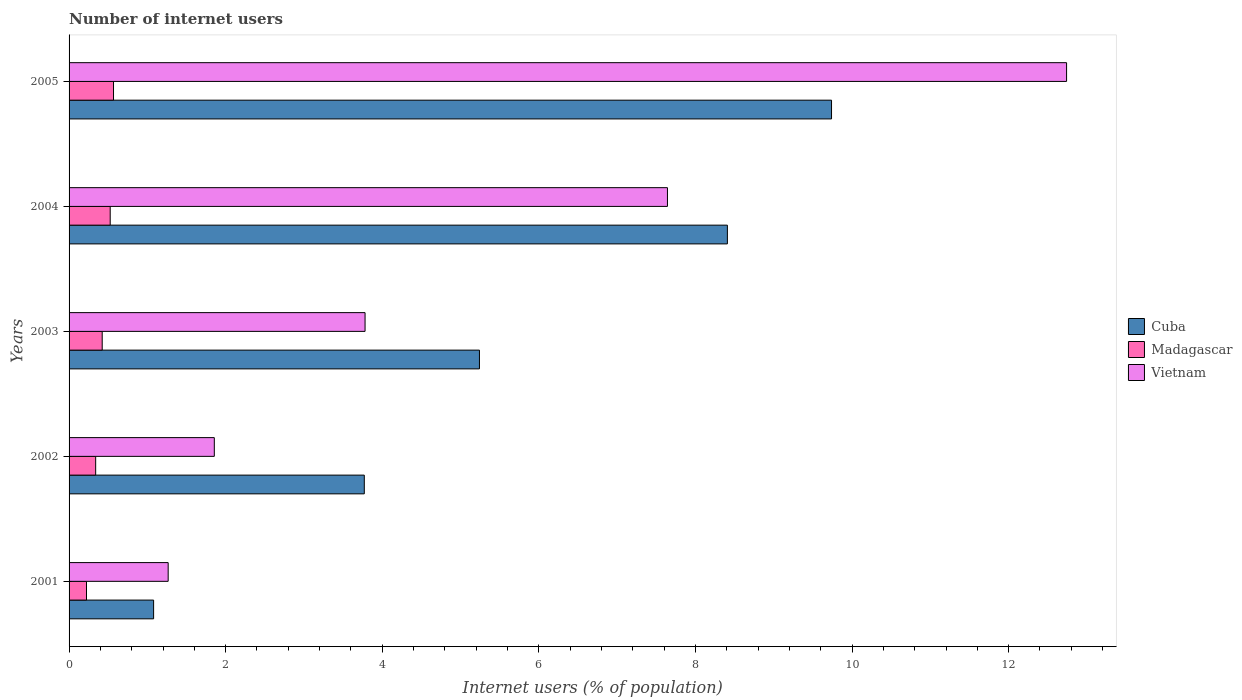How many different coloured bars are there?
Keep it short and to the point. 3. Are the number of bars per tick equal to the number of legend labels?
Provide a short and direct response. Yes. Are the number of bars on each tick of the Y-axis equal?
Offer a terse response. Yes. What is the number of internet users in Vietnam in 2002?
Your answer should be very brief. 1.85. Across all years, what is the maximum number of internet users in Madagascar?
Ensure brevity in your answer.  0.57. Across all years, what is the minimum number of internet users in Vietnam?
Offer a very short reply. 1.27. In which year was the number of internet users in Cuba maximum?
Provide a succinct answer. 2005. What is the total number of internet users in Cuba in the graph?
Provide a short and direct response. 28.24. What is the difference between the number of internet users in Madagascar in 2001 and that in 2002?
Your answer should be very brief. -0.12. What is the difference between the number of internet users in Cuba in 2005 and the number of internet users in Vietnam in 2002?
Provide a short and direct response. 7.88. What is the average number of internet users in Vietnam per year?
Give a very brief answer. 5.46. In the year 2004, what is the difference between the number of internet users in Vietnam and number of internet users in Madagascar?
Offer a very short reply. 7.12. What is the ratio of the number of internet users in Madagascar in 2003 to that in 2004?
Offer a very short reply. 0.81. What is the difference between the highest and the second highest number of internet users in Vietnam?
Offer a terse response. 5.1. What is the difference between the highest and the lowest number of internet users in Vietnam?
Keep it short and to the point. 11.47. In how many years, is the number of internet users in Cuba greater than the average number of internet users in Cuba taken over all years?
Give a very brief answer. 2. What does the 1st bar from the top in 2002 represents?
Make the answer very short. Vietnam. What does the 3rd bar from the bottom in 2004 represents?
Provide a short and direct response. Vietnam. What is the difference between two consecutive major ticks on the X-axis?
Your answer should be compact. 2. Are the values on the major ticks of X-axis written in scientific E-notation?
Your answer should be compact. No. Where does the legend appear in the graph?
Keep it short and to the point. Center right. How are the legend labels stacked?
Your answer should be very brief. Vertical. What is the title of the graph?
Offer a very short reply. Number of internet users. Does "Lebanon" appear as one of the legend labels in the graph?
Ensure brevity in your answer.  No. What is the label or title of the X-axis?
Give a very brief answer. Internet users (% of population). What is the Internet users (% of population) in Cuba in 2001?
Your answer should be very brief. 1.08. What is the Internet users (% of population) of Madagascar in 2001?
Ensure brevity in your answer.  0.22. What is the Internet users (% of population) in Vietnam in 2001?
Offer a terse response. 1.27. What is the Internet users (% of population) of Cuba in 2002?
Ensure brevity in your answer.  3.77. What is the Internet users (% of population) of Madagascar in 2002?
Your answer should be compact. 0.34. What is the Internet users (% of population) of Vietnam in 2002?
Keep it short and to the point. 1.85. What is the Internet users (% of population) of Cuba in 2003?
Provide a succinct answer. 5.24. What is the Internet users (% of population) in Madagascar in 2003?
Make the answer very short. 0.42. What is the Internet users (% of population) in Vietnam in 2003?
Your response must be concise. 3.78. What is the Internet users (% of population) in Cuba in 2004?
Ensure brevity in your answer.  8.41. What is the Internet users (% of population) in Madagascar in 2004?
Ensure brevity in your answer.  0.53. What is the Internet users (% of population) of Vietnam in 2004?
Your response must be concise. 7.64. What is the Internet users (% of population) in Cuba in 2005?
Offer a terse response. 9.74. What is the Internet users (% of population) in Madagascar in 2005?
Your answer should be compact. 0.57. What is the Internet users (% of population) in Vietnam in 2005?
Your answer should be compact. 12.74. Across all years, what is the maximum Internet users (% of population) in Cuba?
Your response must be concise. 9.74. Across all years, what is the maximum Internet users (% of population) in Madagascar?
Keep it short and to the point. 0.57. Across all years, what is the maximum Internet users (% of population) of Vietnam?
Offer a very short reply. 12.74. Across all years, what is the minimum Internet users (% of population) of Cuba?
Offer a terse response. 1.08. Across all years, what is the minimum Internet users (% of population) of Madagascar?
Keep it short and to the point. 0.22. Across all years, what is the minimum Internet users (% of population) in Vietnam?
Keep it short and to the point. 1.27. What is the total Internet users (% of population) in Cuba in the graph?
Your answer should be compact. 28.24. What is the total Internet users (% of population) in Madagascar in the graph?
Ensure brevity in your answer.  2.08. What is the total Internet users (% of population) in Vietnam in the graph?
Provide a succinct answer. 27.28. What is the difference between the Internet users (% of population) of Cuba in 2001 and that in 2002?
Offer a terse response. -2.69. What is the difference between the Internet users (% of population) of Madagascar in 2001 and that in 2002?
Your response must be concise. -0.12. What is the difference between the Internet users (% of population) of Vietnam in 2001 and that in 2002?
Make the answer very short. -0.59. What is the difference between the Internet users (% of population) in Cuba in 2001 and that in 2003?
Your answer should be compact. -4.16. What is the difference between the Internet users (% of population) of Madagascar in 2001 and that in 2003?
Give a very brief answer. -0.2. What is the difference between the Internet users (% of population) of Vietnam in 2001 and that in 2003?
Your response must be concise. -2.51. What is the difference between the Internet users (% of population) of Cuba in 2001 and that in 2004?
Your answer should be very brief. -7.33. What is the difference between the Internet users (% of population) in Madagascar in 2001 and that in 2004?
Provide a succinct answer. -0.3. What is the difference between the Internet users (% of population) in Vietnam in 2001 and that in 2004?
Offer a very short reply. -6.38. What is the difference between the Internet users (% of population) in Cuba in 2001 and that in 2005?
Offer a terse response. -8.66. What is the difference between the Internet users (% of population) of Madagascar in 2001 and that in 2005?
Offer a very short reply. -0.35. What is the difference between the Internet users (% of population) of Vietnam in 2001 and that in 2005?
Provide a succinct answer. -11.47. What is the difference between the Internet users (% of population) in Cuba in 2002 and that in 2003?
Keep it short and to the point. -1.47. What is the difference between the Internet users (% of population) of Madagascar in 2002 and that in 2003?
Offer a very short reply. -0.08. What is the difference between the Internet users (% of population) of Vietnam in 2002 and that in 2003?
Your answer should be very brief. -1.93. What is the difference between the Internet users (% of population) in Cuba in 2002 and that in 2004?
Offer a very short reply. -4.64. What is the difference between the Internet users (% of population) in Madagascar in 2002 and that in 2004?
Give a very brief answer. -0.19. What is the difference between the Internet users (% of population) in Vietnam in 2002 and that in 2004?
Keep it short and to the point. -5.79. What is the difference between the Internet users (% of population) in Cuba in 2002 and that in 2005?
Give a very brief answer. -5.97. What is the difference between the Internet users (% of population) of Madagascar in 2002 and that in 2005?
Your response must be concise. -0.23. What is the difference between the Internet users (% of population) of Vietnam in 2002 and that in 2005?
Make the answer very short. -10.88. What is the difference between the Internet users (% of population) in Cuba in 2003 and that in 2004?
Your answer should be compact. -3.17. What is the difference between the Internet users (% of population) of Madagascar in 2003 and that in 2004?
Your answer should be compact. -0.1. What is the difference between the Internet users (% of population) of Vietnam in 2003 and that in 2004?
Provide a short and direct response. -3.86. What is the difference between the Internet users (% of population) of Cuba in 2003 and that in 2005?
Provide a succinct answer. -4.5. What is the difference between the Internet users (% of population) of Madagascar in 2003 and that in 2005?
Your response must be concise. -0.14. What is the difference between the Internet users (% of population) of Vietnam in 2003 and that in 2005?
Keep it short and to the point. -8.96. What is the difference between the Internet users (% of population) in Cuba in 2004 and that in 2005?
Give a very brief answer. -1.33. What is the difference between the Internet users (% of population) in Madagascar in 2004 and that in 2005?
Ensure brevity in your answer.  -0.04. What is the difference between the Internet users (% of population) in Vietnam in 2004 and that in 2005?
Your response must be concise. -5.1. What is the difference between the Internet users (% of population) in Cuba in 2001 and the Internet users (% of population) in Madagascar in 2002?
Your answer should be compact. 0.74. What is the difference between the Internet users (% of population) in Cuba in 2001 and the Internet users (% of population) in Vietnam in 2002?
Offer a terse response. -0.78. What is the difference between the Internet users (% of population) of Madagascar in 2001 and the Internet users (% of population) of Vietnam in 2002?
Provide a succinct answer. -1.63. What is the difference between the Internet users (% of population) in Cuba in 2001 and the Internet users (% of population) in Madagascar in 2003?
Keep it short and to the point. 0.66. What is the difference between the Internet users (% of population) in Cuba in 2001 and the Internet users (% of population) in Vietnam in 2003?
Make the answer very short. -2.7. What is the difference between the Internet users (% of population) in Madagascar in 2001 and the Internet users (% of population) in Vietnam in 2003?
Ensure brevity in your answer.  -3.56. What is the difference between the Internet users (% of population) in Cuba in 2001 and the Internet users (% of population) in Madagascar in 2004?
Your answer should be very brief. 0.55. What is the difference between the Internet users (% of population) of Cuba in 2001 and the Internet users (% of population) of Vietnam in 2004?
Give a very brief answer. -6.56. What is the difference between the Internet users (% of population) of Madagascar in 2001 and the Internet users (% of population) of Vietnam in 2004?
Give a very brief answer. -7.42. What is the difference between the Internet users (% of population) in Cuba in 2001 and the Internet users (% of population) in Madagascar in 2005?
Make the answer very short. 0.51. What is the difference between the Internet users (% of population) in Cuba in 2001 and the Internet users (% of population) in Vietnam in 2005?
Your response must be concise. -11.66. What is the difference between the Internet users (% of population) in Madagascar in 2001 and the Internet users (% of population) in Vietnam in 2005?
Provide a short and direct response. -12.52. What is the difference between the Internet users (% of population) of Cuba in 2002 and the Internet users (% of population) of Madagascar in 2003?
Make the answer very short. 3.35. What is the difference between the Internet users (% of population) in Cuba in 2002 and the Internet users (% of population) in Vietnam in 2003?
Your answer should be very brief. -0.01. What is the difference between the Internet users (% of population) of Madagascar in 2002 and the Internet users (% of population) of Vietnam in 2003?
Provide a succinct answer. -3.44. What is the difference between the Internet users (% of population) in Cuba in 2002 and the Internet users (% of population) in Madagascar in 2004?
Your answer should be very brief. 3.25. What is the difference between the Internet users (% of population) of Cuba in 2002 and the Internet users (% of population) of Vietnam in 2004?
Provide a short and direct response. -3.87. What is the difference between the Internet users (% of population) of Madagascar in 2002 and the Internet users (% of population) of Vietnam in 2004?
Offer a terse response. -7.3. What is the difference between the Internet users (% of population) in Cuba in 2002 and the Internet users (% of population) in Madagascar in 2005?
Make the answer very short. 3.2. What is the difference between the Internet users (% of population) of Cuba in 2002 and the Internet users (% of population) of Vietnam in 2005?
Ensure brevity in your answer.  -8.97. What is the difference between the Internet users (% of population) of Madagascar in 2002 and the Internet users (% of population) of Vietnam in 2005?
Provide a succinct answer. -12.4. What is the difference between the Internet users (% of population) in Cuba in 2003 and the Internet users (% of population) in Madagascar in 2004?
Make the answer very short. 4.72. What is the difference between the Internet users (% of population) in Cuba in 2003 and the Internet users (% of population) in Vietnam in 2004?
Offer a terse response. -2.4. What is the difference between the Internet users (% of population) in Madagascar in 2003 and the Internet users (% of population) in Vietnam in 2004?
Your answer should be very brief. -7.22. What is the difference between the Internet users (% of population) in Cuba in 2003 and the Internet users (% of population) in Madagascar in 2005?
Offer a very short reply. 4.67. What is the difference between the Internet users (% of population) in Cuba in 2003 and the Internet users (% of population) in Vietnam in 2005?
Make the answer very short. -7.5. What is the difference between the Internet users (% of population) of Madagascar in 2003 and the Internet users (% of population) of Vietnam in 2005?
Give a very brief answer. -12.32. What is the difference between the Internet users (% of population) in Cuba in 2004 and the Internet users (% of population) in Madagascar in 2005?
Ensure brevity in your answer.  7.84. What is the difference between the Internet users (% of population) of Cuba in 2004 and the Internet users (% of population) of Vietnam in 2005?
Offer a terse response. -4.33. What is the difference between the Internet users (% of population) in Madagascar in 2004 and the Internet users (% of population) in Vietnam in 2005?
Your answer should be compact. -12.21. What is the average Internet users (% of population) in Cuba per year?
Ensure brevity in your answer.  5.65. What is the average Internet users (% of population) of Madagascar per year?
Keep it short and to the point. 0.42. What is the average Internet users (% of population) of Vietnam per year?
Provide a succinct answer. 5.46. In the year 2001, what is the difference between the Internet users (% of population) of Cuba and Internet users (% of population) of Madagascar?
Your answer should be compact. 0.86. In the year 2001, what is the difference between the Internet users (% of population) in Cuba and Internet users (% of population) in Vietnam?
Keep it short and to the point. -0.19. In the year 2001, what is the difference between the Internet users (% of population) of Madagascar and Internet users (% of population) of Vietnam?
Provide a short and direct response. -1.04. In the year 2002, what is the difference between the Internet users (% of population) of Cuba and Internet users (% of population) of Madagascar?
Make the answer very short. 3.43. In the year 2002, what is the difference between the Internet users (% of population) in Cuba and Internet users (% of population) in Vietnam?
Your answer should be very brief. 1.92. In the year 2002, what is the difference between the Internet users (% of population) of Madagascar and Internet users (% of population) of Vietnam?
Make the answer very short. -1.52. In the year 2003, what is the difference between the Internet users (% of population) of Cuba and Internet users (% of population) of Madagascar?
Provide a short and direct response. 4.82. In the year 2003, what is the difference between the Internet users (% of population) of Cuba and Internet users (% of population) of Vietnam?
Your response must be concise. 1.46. In the year 2003, what is the difference between the Internet users (% of population) of Madagascar and Internet users (% of population) of Vietnam?
Give a very brief answer. -3.36. In the year 2004, what is the difference between the Internet users (% of population) in Cuba and Internet users (% of population) in Madagascar?
Provide a succinct answer. 7.88. In the year 2004, what is the difference between the Internet users (% of population) of Cuba and Internet users (% of population) of Vietnam?
Your answer should be compact. 0.77. In the year 2004, what is the difference between the Internet users (% of population) of Madagascar and Internet users (% of population) of Vietnam?
Make the answer very short. -7.12. In the year 2005, what is the difference between the Internet users (% of population) of Cuba and Internet users (% of population) of Madagascar?
Your answer should be compact. 9.17. In the year 2005, what is the difference between the Internet users (% of population) of Cuba and Internet users (% of population) of Vietnam?
Keep it short and to the point. -3. In the year 2005, what is the difference between the Internet users (% of population) in Madagascar and Internet users (% of population) in Vietnam?
Give a very brief answer. -12.17. What is the ratio of the Internet users (% of population) in Cuba in 2001 to that in 2002?
Ensure brevity in your answer.  0.29. What is the ratio of the Internet users (% of population) in Madagascar in 2001 to that in 2002?
Offer a terse response. 0.66. What is the ratio of the Internet users (% of population) of Vietnam in 2001 to that in 2002?
Make the answer very short. 0.68. What is the ratio of the Internet users (% of population) in Cuba in 2001 to that in 2003?
Your answer should be very brief. 0.21. What is the ratio of the Internet users (% of population) in Madagascar in 2001 to that in 2003?
Offer a terse response. 0.53. What is the ratio of the Internet users (% of population) in Vietnam in 2001 to that in 2003?
Provide a succinct answer. 0.33. What is the ratio of the Internet users (% of population) of Cuba in 2001 to that in 2004?
Ensure brevity in your answer.  0.13. What is the ratio of the Internet users (% of population) of Madagascar in 2001 to that in 2004?
Ensure brevity in your answer.  0.42. What is the ratio of the Internet users (% of population) of Vietnam in 2001 to that in 2004?
Your response must be concise. 0.17. What is the ratio of the Internet users (% of population) in Cuba in 2001 to that in 2005?
Your answer should be compact. 0.11. What is the ratio of the Internet users (% of population) in Madagascar in 2001 to that in 2005?
Offer a terse response. 0.39. What is the ratio of the Internet users (% of population) in Vietnam in 2001 to that in 2005?
Your answer should be very brief. 0.1. What is the ratio of the Internet users (% of population) in Cuba in 2002 to that in 2003?
Your response must be concise. 0.72. What is the ratio of the Internet users (% of population) in Madagascar in 2002 to that in 2003?
Provide a short and direct response. 0.8. What is the ratio of the Internet users (% of population) in Vietnam in 2002 to that in 2003?
Your response must be concise. 0.49. What is the ratio of the Internet users (% of population) in Cuba in 2002 to that in 2004?
Offer a terse response. 0.45. What is the ratio of the Internet users (% of population) of Madagascar in 2002 to that in 2004?
Give a very brief answer. 0.65. What is the ratio of the Internet users (% of population) of Vietnam in 2002 to that in 2004?
Your response must be concise. 0.24. What is the ratio of the Internet users (% of population) of Cuba in 2002 to that in 2005?
Provide a succinct answer. 0.39. What is the ratio of the Internet users (% of population) in Madagascar in 2002 to that in 2005?
Give a very brief answer. 0.6. What is the ratio of the Internet users (% of population) in Vietnam in 2002 to that in 2005?
Offer a terse response. 0.15. What is the ratio of the Internet users (% of population) in Cuba in 2003 to that in 2004?
Give a very brief answer. 0.62. What is the ratio of the Internet users (% of population) in Madagascar in 2003 to that in 2004?
Your answer should be very brief. 0.81. What is the ratio of the Internet users (% of population) in Vietnam in 2003 to that in 2004?
Provide a short and direct response. 0.49. What is the ratio of the Internet users (% of population) of Cuba in 2003 to that in 2005?
Your response must be concise. 0.54. What is the ratio of the Internet users (% of population) of Madagascar in 2003 to that in 2005?
Make the answer very short. 0.75. What is the ratio of the Internet users (% of population) of Vietnam in 2003 to that in 2005?
Provide a succinct answer. 0.3. What is the ratio of the Internet users (% of population) of Cuba in 2004 to that in 2005?
Provide a succinct answer. 0.86. What is the ratio of the Internet users (% of population) in Madagascar in 2004 to that in 2005?
Offer a very short reply. 0.93. What is the ratio of the Internet users (% of population) of Vietnam in 2004 to that in 2005?
Keep it short and to the point. 0.6. What is the difference between the highest and the second highest Internet users (% of population) of Cuba?
Ensure brevity in your answer.  1.33. What is the difference between the highest and the second highest Internet users (% of population) of Madagascar?
Your response must be concise. 0.04. What is the difference between the highest and the second highest Internet users (% of population) of Vietnam?
Keep it short and to the point. 5.1. What is the difference between the highest and the lowest Internet users (% of population) in Cuba?
Keep it short and to the point. 8.66. What is the difference between the highest and the lowest Internet users (% of population) in Madagascar?
Provide a succinct answer. 0.35. What is the difference between the highest and the lowest Internet users (% of population) of Vietnam?
Keep it short and to the point. 11.47. 